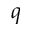<formula> <loc_0><loc_0><loc_500><loc_500>q</formula> 